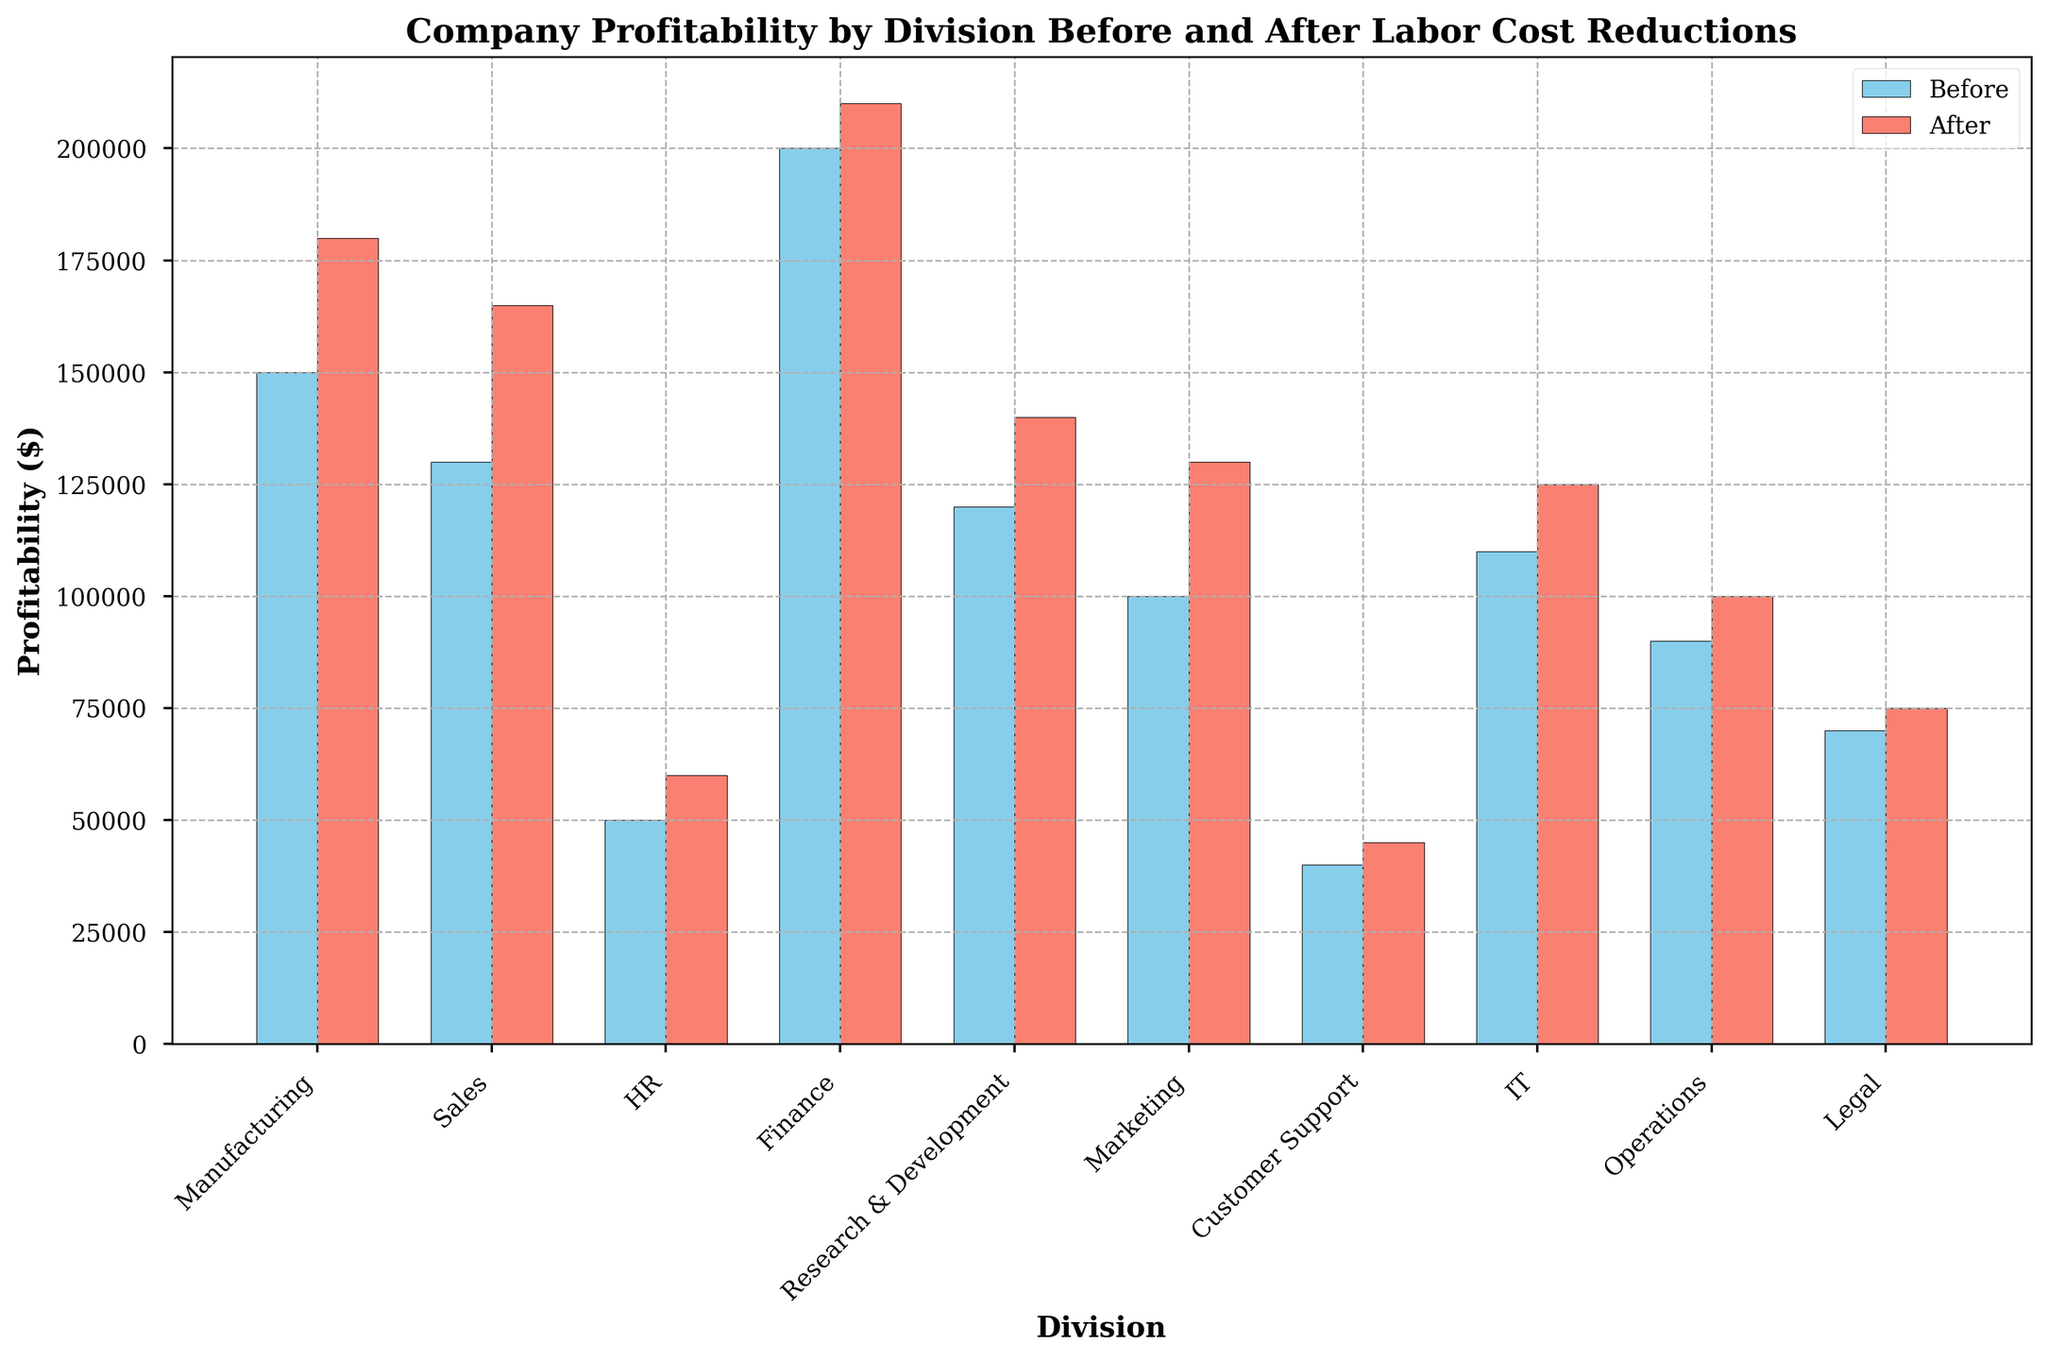Which division showed the highest increase in profitability after labor cost reductions? To find the division with the highest increase, look at the difference in bar heights for each division before and after labor cost reductions. The biggest difference will indicate the highest increase in profitability. For example, compare Manufacturing (150,000 to 180,000) with other divisions.
Answer: Sales What is the total profitability of the HR division before and after labor cost reductions? Sum the profitability values for the HR division before and after labor cost reductions. Before, it is 50,000 and after, it is 60,000. Adding these gives 50,000 + 60,000 = 110,000.
Answer: 110,000 Which division had the least increase in profitability after labor cost reductions? To identify this, look for the smallest difference in bar heights for each division before and after labor cost reductions. For example, compare Customer Support (40,000 to 45,000) to other divisions.
Answer: Customer Support What's the average profitability for Sales, Marketing, and IT after labor cost reductions? Add the profitability values for these divisions after labor cost reductions (165,000 for Sales, 130,000 for Marketing, and 125,000 for IT). Then divide by the number of divisions. (165,000 + 130,000 + 125,000) / 3 = 420,000 / 3.
Answer: 140,000 Is the profitability of the Finance division higher than that of the Manufacturing division after labor cost reductions? Compare the bar heights of the Finance division (210,000) and the Manufacturing division (180,000) after labor cost reductions. 210,000 is greater than 180,000.
Answer: Yes By how much did the profitability of the Legal division increase after labor cost reductions in percentage terms? First, find the absolute increase in profitability for the Legal division (from 70,000 to 75,000). Absolute increase is 75,000 - 70,000 = 5,000. To find the percentage increase, (5,000 / 70,000) * 100 = 7.14%.
Answer: 7.14% What is the sum of the profitability for Operations and Research & Development divisions after labor cost reductions? Add the profitability values for both divisions after labor cost reductions (100,000 for Operations and 140,000 for Research & Development). Sum is 100,000 + 140,000 = 240,000.
Answer: 240,000 Which division had the smallest profitability before labor cost reductions? Look at the bar heights for all divisions before labor cost reductions and find the smallest one. Customer Support is the lowest at 40,000.
Answer: Customer Support 